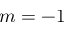<formula> <loc_0><loc_0><loc_500><loc_500>m = - 1</formula> 